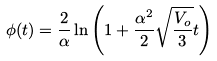<formula> <loc_0><loc_0><loc_500><loc_500>\phi ( t ) = \frac { 2 } { \alpha } \ln \left ( 1 + \frac { \alpha ^ { 2 } } { 2 } \sqrt { \frac { V _ { o } } { 3 } } t \right )</formula> 